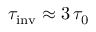Convert formula to latex. <formula><loc_0><loc_0><loc_500><loc_500>\tau _ { i n v } \approx 3 \, \tau _ { 0 }</formula> 